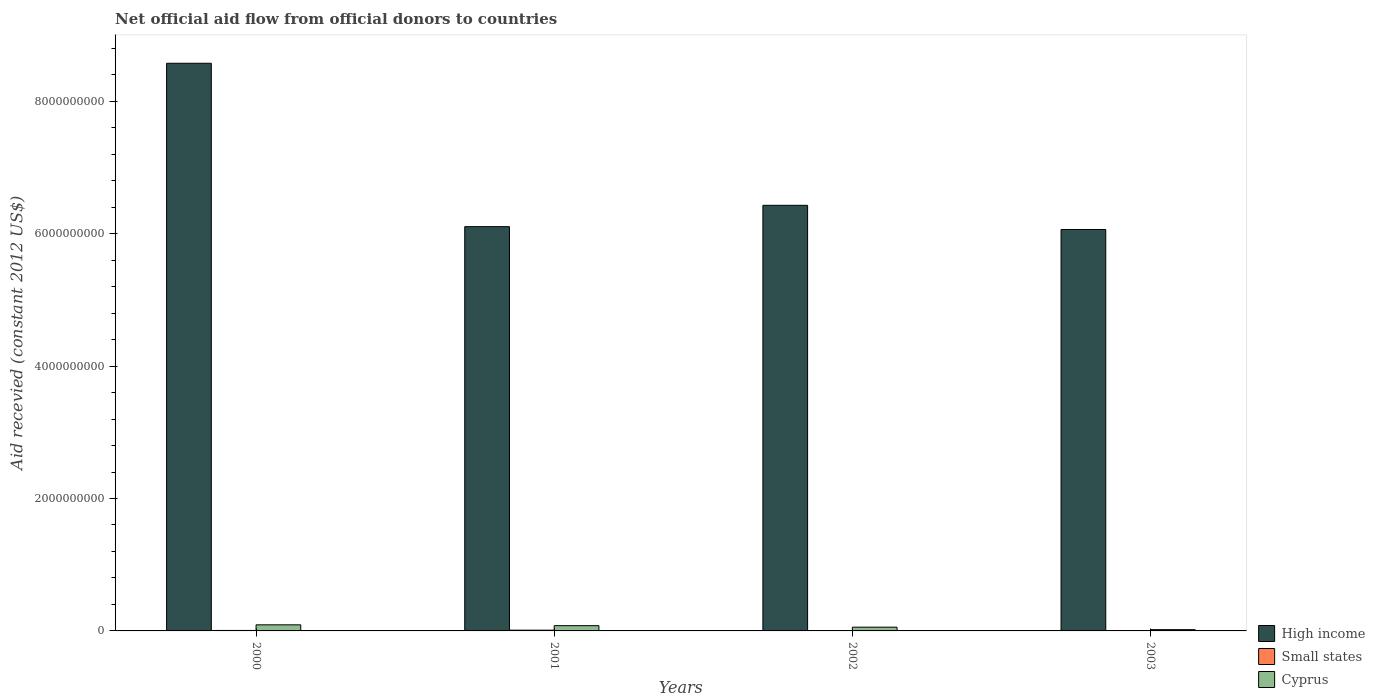How many groups of bars are there?
Your answer should be very brief. 4. Are the number of bars per tick equal to the number of legend labels?
Offer a terse response. Yes. How many bars are there on the 4th tick from the left?
Ensure brevity in your answer.  3. What is the label of the 4th group of bars from the left?
Keep it short and to the point. 2003. In how many cases, is the number of bars for a given year not equal to the number of legend labels?
Provide a short and direct response. 0. What is the total aid received in Small states in 2001?
Make the answer very short. 1.14e+07. Across all years, what is the maximum total aid received in Cyprus?
Provide a short and direct response. 9.20e+07. Across all years, what is the minimum total aid received in High income?
Offer a very short reply. 6.06e+09. What is the total total aid received in High income in the graph?
Provide a succinct answer. 2.72e+1. What is the difference between the total aid received in High income in 2000 and that in 2002?
Your response must be concise. 2.15e+09. What is the difference between the total aid received in High income in 2000 and the total aid received in Small states in 2003?
Your answer should be compact. 8.57e+09. What is the average total aid received in Cyprus per year?
Make the answer very short. 6.18e+07. In the year 2002, what is the difference between the total aid received in High income and total aid received in Cyprus?
Make the answer very short. 6.37e+09. In how many years, is the total aid received in High income greater than 7200000000 US$?
Provide a short and direct response. 1. What is the ratio of the total aid received in Cyprus in 2001 to that in 2002?
Your response must be concise. 1.4. Is the difference between the total aid received in High income in 2000 and 2003 greater than the difference between the total aid received in Cyprus in 2000 and 2003?
Your answer should be compact. Yes. What is the difference between the highest and the second highest total aid received in Cyprus?
Your answer should be very brief. 1.25e+07. What is the difference between the highest and the lowest total aid received in High income?
Give a very brief answer. 2.51e+09. In how many years, is the total aid received in High income greater than the average total aid received in High income taken over all years?
Offer a very short reply. 1. What does the 3rd bar from the left in 2000 represents?
Keep it short and to the point. Cyprus. What does the 2nd bar from the right in 2001 represents?
Offer a terse response. Small states. Is it the case that in every year, the sum of the total aid received in Small states and total aid received in High income is greater than the total aid received in Cyprus?
Ensure brevity in your answer.  Yes. Where does the legend appear in the graph?
Provide a short and direct response. Bottom right. What is the title of the graph?
Your response must be concise. Net official aid flow from official donors to countries. Does "Korea (Democratic)" appear as one of the legend labels in the graph?
Provide a short and direct response. No. What is the label or title of the Y-axis?
Offer a terse response. Aid recevied (constant 2012 US$). What is the Aid recevied (constant 2012 US$) in High income in 2000?
Provide a succinct answer. 8.57e+09. What is the Aid recevied (constant 2012 US$) of Small states in 2000?
Provide a succinct answer. 7.08e+06. What is the Aid recevied (constant 2012 US$) in Cyprus in 2000?
Provide a succinct answer. 9.20e+07. What is the Aid recevied (constant 2012 US$) in High income in 2001?
Offer a very short reply. 6.11e+09. What is the Aid recevied (constant 2012 US$) in Small states in 2001?
Provide a succinct answer. 1.14e+07. What is the Aid recevied (constant 2012 US$) of Cyprus in 2001?
Ensure brevity in your answer.  7.95e+07. What is the Aid recevied (constant 2012 US$) of High income in 2002?
Your answer should be very brief. 6.43e+09. What is the Aid recevied (constant 2012 US$) of Small states in 2002?
Keep it short and to the point. 5.78e+06. What is the Aid recevied (constant 2012 US$) of Cyprus in 2002?
Make the answer very short. 5.66e+07. What is the Aid recevied (constant 2012 US$) of High income in 2003?
Offer a terse response. 6.06e+09. What is the Aid recevied (constant 2012 US$) in Small states in 2003?
Give a very brief answer. 4.76e+06. What is the Aid recevied (constant 2012 US$) of Cyprus in 2003?
Give a very brief answer. 1.92e+07. Across all years, what is the maximum Aid recevied (constant 2012 US$) of High income?
Keep it short and to the point. 8.57e+09. Across all years, what is the maximum Aid recevied (constant 2012 US$) of Small states?
Provide a short and direct response. 1.14e+07. Across all years, what is the maximum Aid recevied (constant 2012 US$) of Cyprus?
Make the answer very short. 9.20e+07. Across all years, what is the minimum Aid recevied (constant 2012 US$) of High income?
Provide a short and direct response. 6.06e+09. Across all years, what is the minimum Aid recevied (constant 2012 US$) of Small states?
Your response must be concise. 4.76e+06. Across all years, what is the minimum Aid recevied (constant 2012 US$) in Cyprus?
Your answer should be very brief. 1.92e+07. What is the total Aid recevied (constant 2012 US$) in High income in the graph?
Ensure brevity in your answer.  2.72e+1. What is the total Aid recevied (constant 2012 US$) in Small states in the graph?
Offer a terse response. 2.90e+07. What is the total Aid recevied (constant 2012 US$) of Cyprus in the graph?
Your answer should be very brief. 2.47e+08. What is the difference between the Aid recevied (constant 2012 US$) of High income in 2000 and that in 2001?
Give a very brief answer. 2.47e+09. What is the difference between the Aid recevied (constant 2012 US$) of Small states in 2000 and that in 2001?
Ensure brevity in your answer.  -4.30e+06. What is the difference between the Aid recevied (constant 2012 US$) in Cyprus in 2000 and that in 2001?
Offer a very short reply. 1.25e+07. What is the difference between the Aid recevied (constant 2012 US$) of High income in 2000 and that in 2002?
Your answer should be very brief. 2.15e+09. What is the difference between the Aid recevied (constant 2012 US$) in Small states in 2000 and that in 2002?
Ensure brevity in your answer.  1.30e+06. What is the difference between the Aid recevied (constant 2012 US$) in Cyprus in 2000 and that in 2002?
Provide a succinct answer. 3.53e+07. What is the difference between the Aid recevied (constant 2012 US$) of High income in 2000 and that in 2003?
Offer a very short reply. 2.51e+09. What is the difference between the Aid recevied (constant 2012 US$) in Small states in 2000 and that in 2003?
Give a very brief answer. 2.32e+06. What is the difference between the Aid recevied (constant 2012 US$) of Cyprus in 2000 and that in 2003?
Offer a very short reply. 7.27e+07. What is the difference between the Aid recevied (constant 2012 US$) in High income in 2001 and that in 2002?
Offer a terse response. -3.22e+08. What is the difference between the Aid recevied (constant 2012 US$) in Small states in 2001 and that in 2002?
Ensure brevity in your answer.  5.60e+06. What is the difference between the Aid recevied (constant 2012 US$) of Cyprus in 2001 and that in 2002?
Your answer should be compact. 2.28e+07. What is the difference between the Aid recevied (constant 2012 US$) of High income in 2001 and that in 2003?
Offer a very short reply. 4.32e+07. What is the difference between the Aid recevied (constant 2012 US$) of Small states in 2001 and that in 2003?
Your response must be concise. 6.62e+06. What is the difference between the Aid recevied (constant 2012 US$) in Cyprus in 2001 and that in 2003?
Make the answer very short. 6.02e+07. What is the difference between the Aid recevied (constant 2012 US$) in High income in 2002 and that in 2003?
Give a very brief answer. 3.65e+08. What is the difference between the Aid recevied (constant 2012 US$) in Small states in 2002 and that in 2003?
Offer a very short reply. 1.02e+06. What is the difference between the Aid recevied (constant 2012 US$) of Cyprus in 2002 and that in 2003?
Ensure brevity in your answer.  3.74e+07. What is the difference between the Aid recevied (constant 2012 US$) of High income in 2000 and the Aid recevied (constant 2012 US$) of Small states in 2001?
Provide a short and direct response. 8.56e+09. What is the difference between the Aid recevied (constant 2012 US$) in High income in 2000 and the Aid recevied (constant 2012 US$) in Cyprus in 2001?
Make the answer very short. 8.49e+09. What is the difference between the Aid recevied (constant 2012 US$) of Small states in 2000 and the Aid recevied (constant 2012 US$) of Cyprus in 2001?
Ensure brevity in your answer.  -7.24e+07. What is the difference between the Aid recevied (constant 2012 US$) of High income in 2000 and the Aid recevied (constant 2012 US$) of Small states in 2002?
Keep it short and to the point. 8.57e+09. What is the difference between the Aid recevied (constant 2012 US$) in High income in 2000 and the Aid recevied (constant 2012 US$) in Cyprus in 2002?
Give a very brief answer. 8.52e+09. What is the difference between the Aid recevied (constant 2012 US$) of Small states in 2000 and the Aid recevied (constant 2012 US$) of Cyprus in 2002?
Offer a terse response. -4.96e+07. What is the difference between the Aid recevied (constant 2012 US$) in High income in 2000 and the Aid recevied (constant 2012 US$) in Small states in 2003?
Give a very brief answer. 8.57e+09. What is the difference between the Aid recevied (constant 2012 US$) in High income in 2000 and the Aid recevied (constant 2012 US$) in Cyprus in 2003?
Ensure brevity in your answer.  8.55e+09. What is the difference between the Aid recevied (constant 2012 US$) of Small states in 2000 and the Aid recevied (constant 2012 US$) of Cyprus in 2003?
Provide a short and direct response. -1.22e+07. What is the difference between the Aid recevied (constant 2012 US$) in High income in 2001 and the Aid recevied (constant 2012 US$) in Small states in 2002?
Make the answer very short. 6.10e+09. What is the difference between the Aid recevied (constant 2012 US$) in High income in 2001 and the Aid recevied (constant 2012 US$) in Cyprus in 2002?
Ensure brevity in your answer.  6.05e+09. What is the difference between the Aid recevied (constant 2012 US$) in Small states in 2001 and the Aid recevied (constant 2012 US$) in Cyprus in 2002?
Offer a very short reply. -4.52e+07. What is the difference between the Aid recevied (constant 2012 US$) in High income in 2001 and the Aid recevied (constant 2012 US$) in Small states in 2003?
Provide a succinct answer. 6.10e+09. What is the difference between the Aid recevied (constant 2012 US$) in High income in 2001 and the Aid recevied (constant 2012 US$) in Cyprus in 2003?
Make the answer very short. 6.09e+09. What is the difference between the Aid recevied (constant 2012 US$) of Small states in 2001 and the Aid recevied (constant 2012 US$) of Cyprus in 2003?
Your response must be concise. -7.85e+06. What is the difference between the Aid recevied (constant 2012 US$) of High income in 2002 and the Aid recevied (constant 2012 US$) of Small states in 2003?
Ensure brevity in your answer.  6.42e+09. What is the difference between the Aid recevied (constant 2012 US$) in High income in 2002 and the Aid recevied (constant 2012 US$) in Cyprus in 2003?
Offer a very short reply. 6.41e+09. What is the difference between the Aid recevied (constant 2012 US$) of Small states in 2002 and the Aid recevied (constant 2012 US$) of Cyprus in 2003?
Make the answer very short. -1.34e+07. What is the average Aid recevied (constant 2012 US$) in High income per year?
Ensure brevity in your answer.  6.79e+09. What is the average Aid recevied (constant 2012 US$) in Small states per year?
Ensure brevity in your answer.  7.25e+06. What is the average Aid recevied (constant 2012 US$) in Cyprus per year?
Ensure brevity in your answer.  6.18e+07. In the year 2000, what is the difference between the Aid recevied (constant 2012 US$) in High income and Aid recevied (constant 2012 US$) in Small states?
Your answer should be compact. 8.57e+09. In the year 2000, what is the difference between the Aid recevied (constant 2012 US$) of High income and Aid recevied (constant 2012 US$) of Cyprus?
Provide a succinct answer. 8.48e+09. In the year 2000, what is the difference between the Aid recevied (constant 2012 US$) of Small states and Aid recevied (constant 2012 US$) of Cyprus?
Your answer should be compact. -8.49e+07. In the year 2001, what is the difference between the Aid recevied (constant 2012 US$) in High income and Aid recevied (constant 2012 US$) in Small states?
Make the answer very short. 6.09e+09. In the year 2001, what is the difference between the Aid recevied (constant 2012 US$) of High income and Aid recevied (constant 2012 US$) of Cyprus?
Give a very brief answer. 6.03e+09. In the year 2001, what is the difference between the Aid recevied (constant 2012 US$) in Small states and Aid recevied (constant 2012 US$) in Cyprus?
Your answer should be compact. -6.81e+07. In the year 2002, what is the difference between the Aid recevied (constant 2012 US$) in High income and Aid recevied (constant 2012 US$) in Small states?
Your response must be concise. 6.42e+09. In the year 2002, what is the difference between the Aid recevied (constant 2012 US$) in High income and Aid recevied (constant 2012 US$) in Cyprus?
Ensure brevity in your answer.  6.37e+09. In the year 2002, what is the difference between the Aid recevied (constant 2012 US$) of Small states and Aid recevied (constant 2012 US$) of Cyprus?
Your answer should be very brief. -5.08e+07. In the year 2003, what is the difference between the Aid recevied (constant 2012 US$) of High income and Aid recevied (constant 2012 US$) of Small states?
Provide a short and direct response. 6.06e+09. In the year 2003, what is the difference between the Aid recevied (constant 2012 US$) in High income and Aid recevied (constant 2012 US$) in Cyprus?
Make the answer very short. 6.04e+09. In the year 2003, what is the difference between the Aid recevied (constant 2012 US$) in Small states and Aid recevied (constant 2012 US$) in Cyprus?
Make the answer very short. -1.45e+07. What is the ratio of the Aid recevied (constant 2012 US$) in High income in 2000 to that in 2001?
Keep it short and to the point. 1.4. What is the ratio of the Aid recevied (constant 2012 US$) of Small states in 2000 to that in 2001?
Your answer should be compact. 0.62. What is the ratio of the Aid recevied (constant 2012 US$) in Cyprus in 2000 to that in 2001?
Offer a terse response. 1.16. What is the ratio of the Aid recevied (constant 2012 US$) in High income in 2000 to that in 2002?
Your answer should be very brief. 1.33. What is the ratio of the Aid recevied (constant 2012 US$) in Small states in 2000 to that in 2002?
Provide a short and direct response. 1.22. What is the ratio of the Aid recevied (constant 2012 US$) in Cyprus in 2000 to that in 2002?
Provide a succinct answer. 1.62. What is the ratio of the Aid recevied (constant 2012 US$) of High income in 2000 to that in 2003?
Provide a succinct answer. 1.41. What is the ratio of the Aid recevied (constant 2012 US$) in Small states in 2000 to that in 2003?
Give a very brief answer. 1.49. What is the ratio of the Aid recevied (constant 2012 US$) in Cyprus in 2000 to that in 2003?
Offer a very short reply. 4.78. What is the ratio of the Aid recevied (constant 2012 US$) in High income in 2001 to that in 2002?
Give a very brief answer. 0.95. What is the ratio of the Aid recevied (constant 2012 US$) of Small states in 2001 to that in 2002?
Provide a succinct answer. 1.97. What is the ratio of the Aid recevied (constant 2012 US$) in Cyprus in 2001 to that in 2002?
Give a very brief answer. 1.4. What is the ratio of the Aid recevied (constant 2012 US$) of High income in 2001 to that in 2003?
Offer a very short reply. 1.01. What is the ratio of the Aid recevied (constant 2012 US$) of Small states in 2001 to that in 2003?
Your response must be concise. 2.39. What is the ratio of the Aid recevied (constant 2012 US$) in Cyprus in 2001 to that in 2003?
Provide a short and direct response. 4.13. What is the ratio of the Aid recevied (constant 2012 US$) of High income in 2002 to that in 2003?
Your answer should be compact. 1.06. What is the ratio of the Aid recevied (constant 2012 US$) in Small states in 2002 to that in 2003?
Provide a short and direct response. 1.21. What is the ratio of the Aid recevied (constant 2012 US$) of Cyprus in 2002 to that in 2003?
Offer a very short reply. 2.94. What is the difference between the highest and the second highest Aid recevied (constant 2012 US$) of High income?
Provide a short and direct response. 2.15e+09. What is the difference between the highest and the second highest Aid recevied (constant 2012 US$) in Small states?
Provide a succinct answer. 4.30e+06. What is the difference between the highest and the second highest Aid recevied (constant 2012 US$) in Cyprus?
Your answer should be very brief. 1.25e+07. What is the difference between the highest and the lowest Aid recevied (constant 2012 US$) in High income?
Offer a very short reply. 2.51e+09. What is the difference between the highest and the lowest Aid recevied (constant 2012 US$) in Small states?
Make the answer very short. 6.62e+06. What is the difference between the highest and the lowest Aid recevied (constant 2012 US$) of Cyprus?
Make the answer very short. 7.27e+07. 